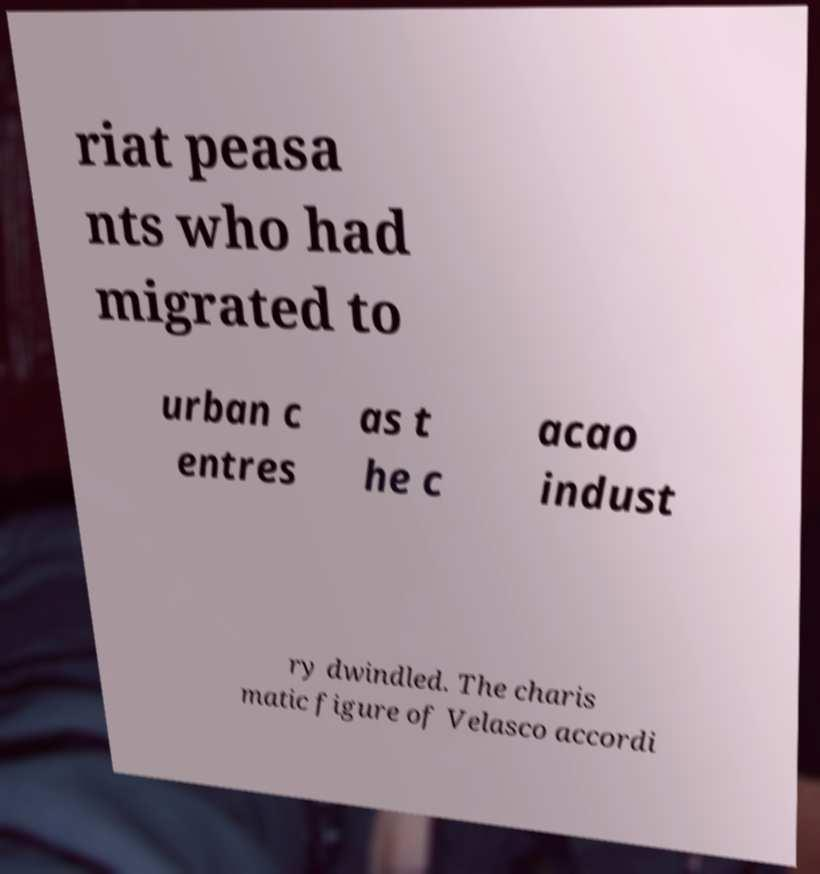Can you accurately transcribe the text from the provided image for me? riat peasa nts who had migrated to urban c entres as t he c acao indust ry dwindled. The charis matic figure of Velasco accordi 